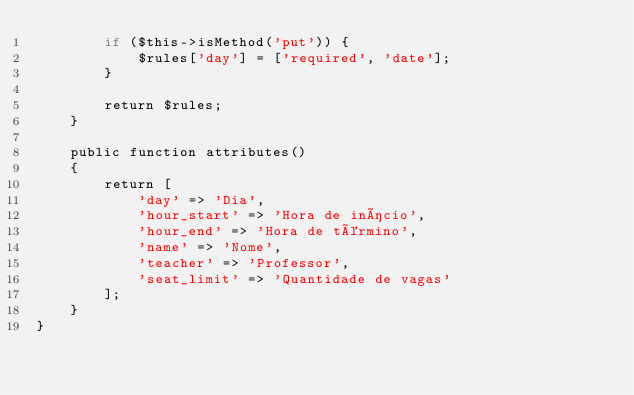Convert code to text. <code><loc_0><loc_0><loc_500><loc_500><_PHP_>        if ($this->isMethod('put')) {
            $rules['day'] = ['required', 'date'];
        }

        return $rules;
    }

    public function attributes()
    {
        return [
            'day' => 'Dia',
            'hour_start' => 'Hora de início',
            'hour_end' => 'Hora de término',
            'name' => 'Nome',
            'teacher' => 'Professor',
            'seat_limit' => 'Quantidade de vagas'
        ];
    }
}
</code> 